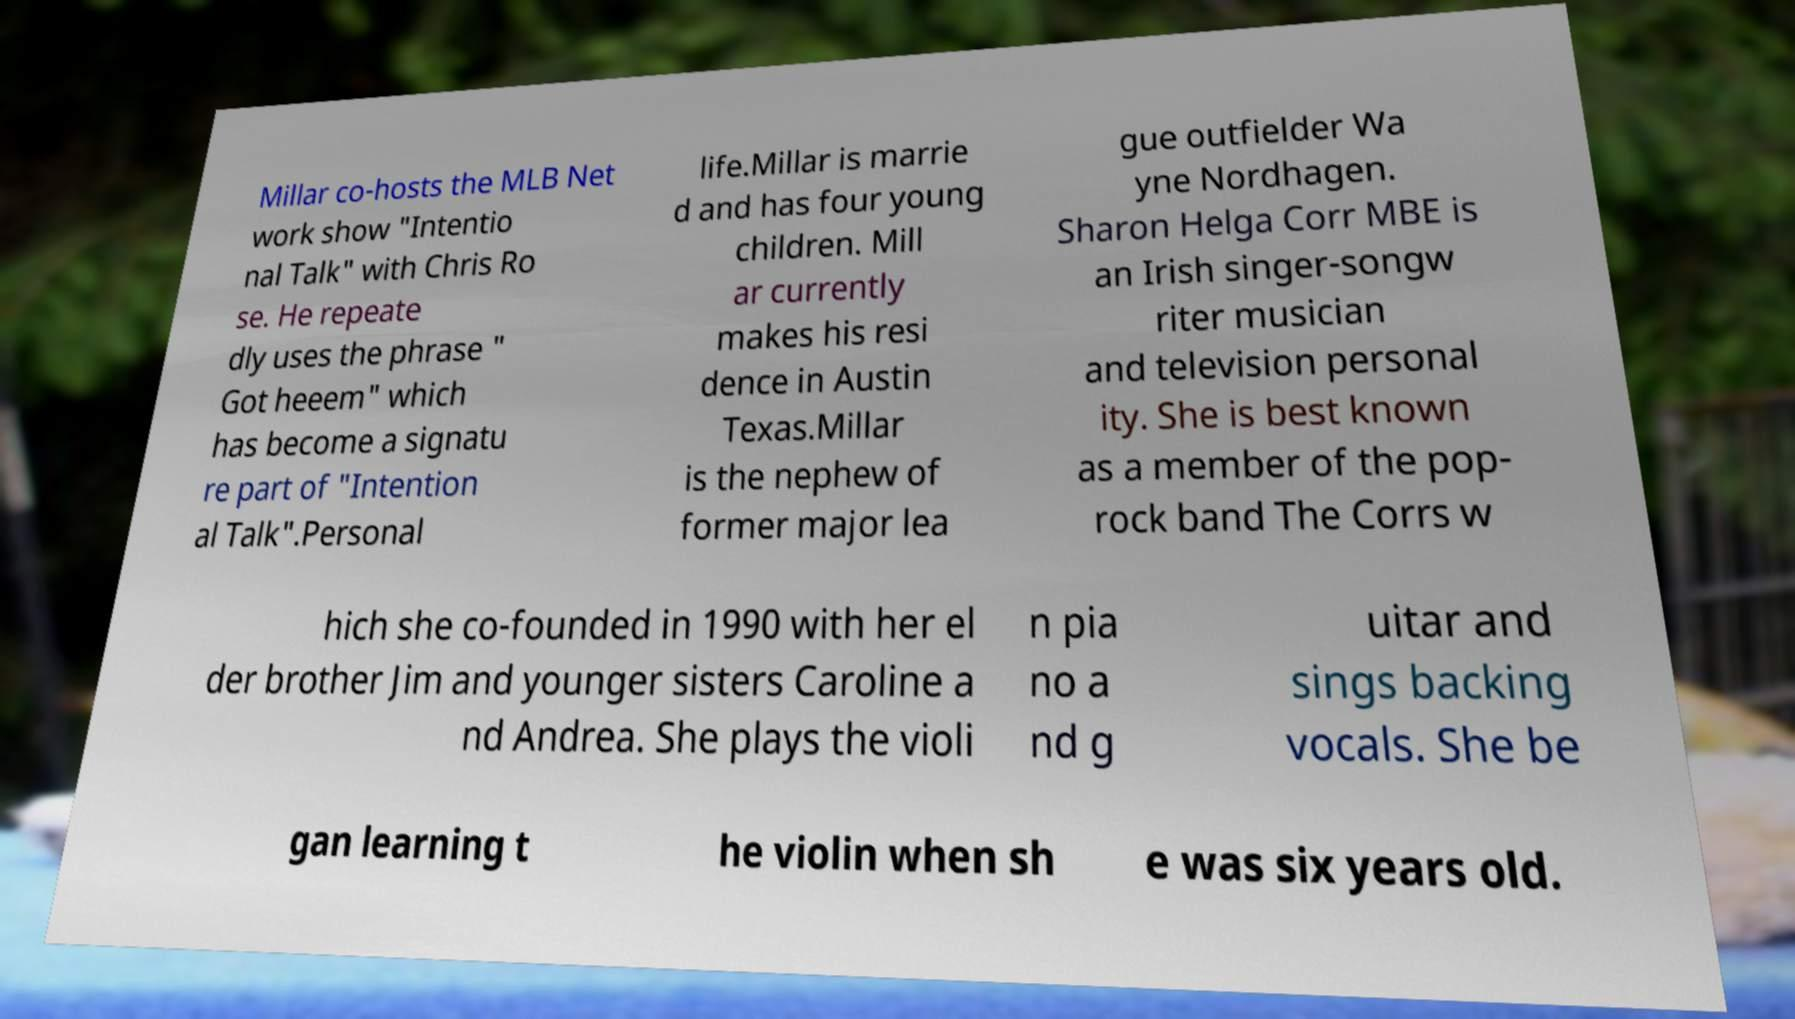There's text embedded in this image that I need extracted. Can you transcribe it verbatim? Millar co-hosts the MLB Net work show "Intentio nal Talk" with Chris Ro se. He repeate dly uses the phrase " Got heeem" which has become a signatu re part of "Intention al Talk".Personal life.Millar is marrie d and has four young children. Mill ar currently makes his resi dence in Austin Texas.Millar is the nephew of former major lea gue outfielder Wa yne Nordhagen. Sharon Helga Corr MBE is an Irish singer-songw riter musician and television personal ity. She is best known as a member of the pop- rock band The Corrs w hich she co-founded in 1990 with her el der brother Jim and younger sisters Caroline a nd Andrea. She plays the violi n pia no a nd g uitar and sings backing vocals. She be gan learning t he violin when sh e was six years old. 